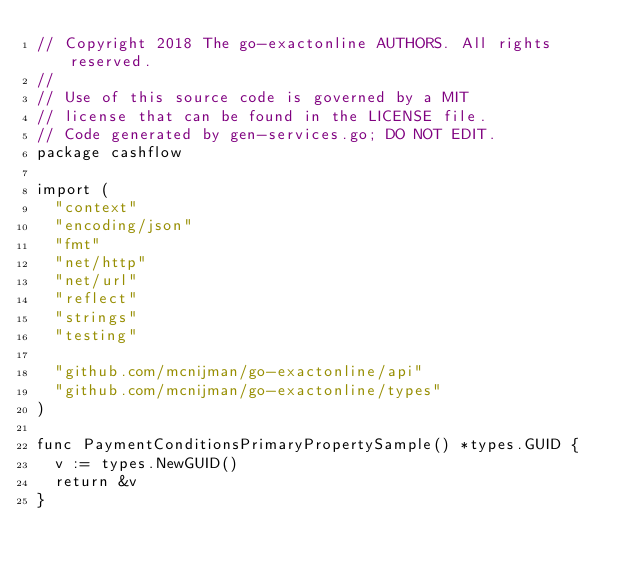Convert code to text. <code><loc_0><loc_0><loc_500><loc_500><_Go_>// Copyright 2018 The go-exactonline AUTHORS. All rights reserved.
//
// Use of this source code is governed by a MIT
// license that can be found in the LICENSE file.
// Code generated by gen-services.go; DO NOT EDIT.
package cashflow

import (
	"context"
	"encoding/json"
	"fmt"
	"net/http"
	"net/url"
	"reflect"
	"strings"
	"testing"

	"github.com/mcnijman/go-exactonline/api"
	"github.com/mcnijman/go-exactonline/types"
)

func PaymentConditionsPrimaryPropertySample() *types.GUID {
	v := types.NewGUID()
	return &v
}
</code> 